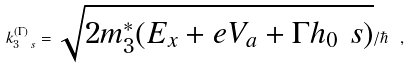Convert formula to latex. <formula><loc_0><loc_0><loc_500><loc_500>k _ { 3 \ s } ^ { ( \Gamma ) } = \sqrt { 2 m _ { 3 } ^ { * } ( E _ { x } + e V _ { a } + \Gamma h _ { 0 } \ s ) } / \hbar { \ } ,</formula> 